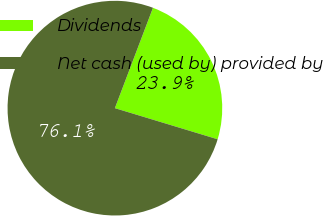Convert chart to OTSL. <chart><loc_0><loc_0><loc_500><loc_500><pie_chart><fcel>Dividends<fcel>Net cash (used by) provided by<nl><fcel>23.91%<fcel>76.09%<nl></chart> 